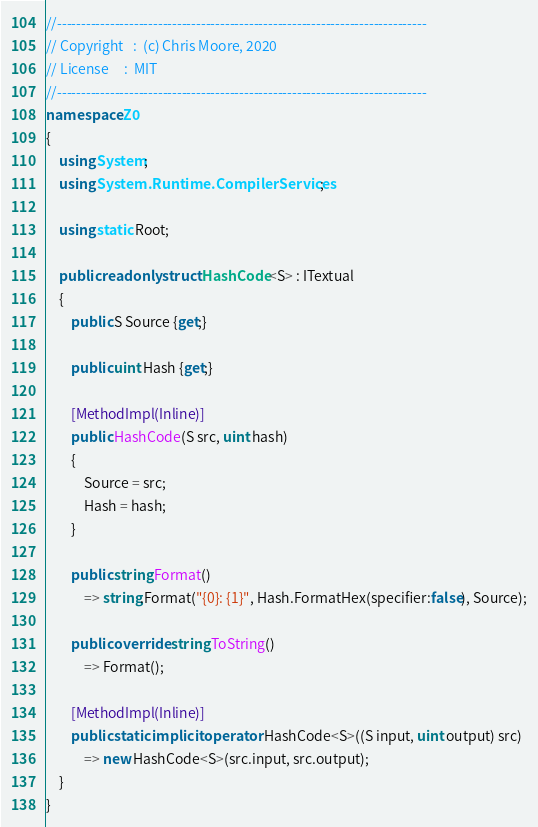Convert code to text. <code><loc_0><loc_0><loc_500><loc_500><_C#_>//-----------------------------------------------------------------------------
// Copyright   :  (c) Chris Moore, 2020
// License     :  MIT
//-----------------------------------------------------------------------------
namespace Z0
{
    using System;
    using System.Runtime.CompilerServices;

    using static Root;

    public readonly struct HashCode<S> : ITextual
    {
        public S Source {get;}

        public uint Hash {get;}

        [MethodImpl(Inline)]
        public HashCode(S src, uint hash)
        {
            Source = src;
            Hash = hash;
        }

        public string Format()
            => string.Format("{0}: {1}", Hash.FormatHex(specifier:false), Source);

        public override string ToString()
            => Format();

        [MethodImpl(Inline)]
        public static implicit operator HashCode<S>((S input, uint output) src)
            => new HashCode<S>(src.input, src.output);
    }
}</code> 